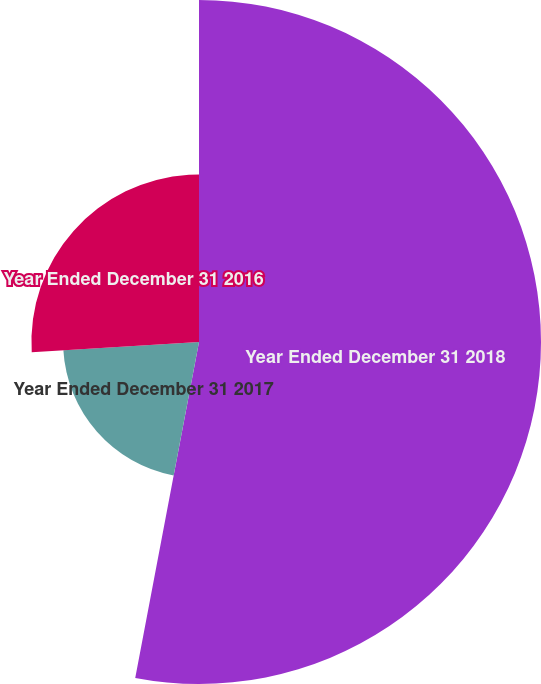Convert chart. <chart><loc_0><loc_0><loc_500><loc_500><pie_chart><fcel>Year Ended December 31 2018<fcel>Year Ended December 31 2017<fcel>Year Ended December 31 2016<nl><fcel>52.98%<fcel>21.05%<fcel>25.96%<nl></chart> 